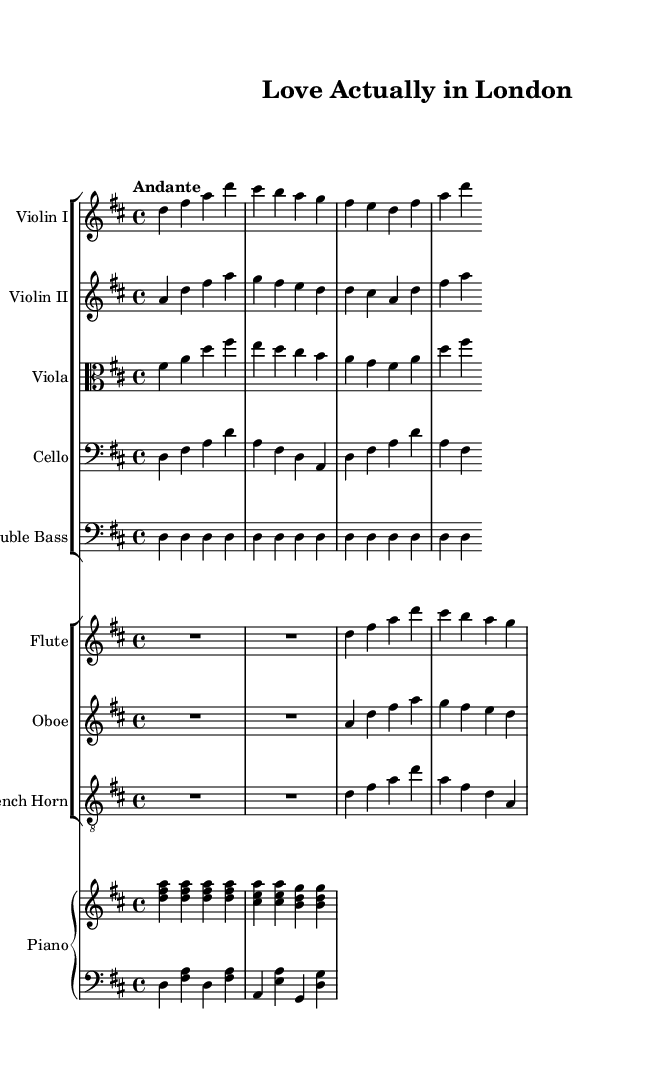What is the key signature of this music? The key signature is indicated at the beginning of the staff, showing two sharps (F# and C#). This indicates the piece is in D major.
Answer: D major What is the time signature of this music? The time signature is shown at the beginning of the score, represented as 4/4, which means there are four beats in each measure with a quarter note receiving one beat.
Answer: 4/4 What is the tempo marking for this piece? The tempo marking is stated at the beginning as "Andante," indicating a moderately slow pace, typically considered at around 76-108 beats per minute.
Answer: Andante How many instruments are scored in this piece? By counting the different staves in the score, there are a total of ten instruments: two violins, one viola, one cello, one double bass, one flute, one oboe, one French horn, and one piano.
Answer: Ten Which string instruments are featured in this orchestration? The score lists four string instruments: Violin I, Violin II, Viola, Cello, and Double Bass. These can be identified by their respective staves in the first group of instruments.
Answer: Five What is the function of the double bass in this orchestration? The double bass provides a harmonic and rhythmic foundation, playing sustained notes (D) that outline the chord progression, enhancing the depth of the orchestration.
Answer: Harmonic foundation Which instrument plays the theme in the highest register? The flute typically plays in a higher register and has the highest notes in this orchestration compared to the strings and other woodwinds.
Answer: Flute 